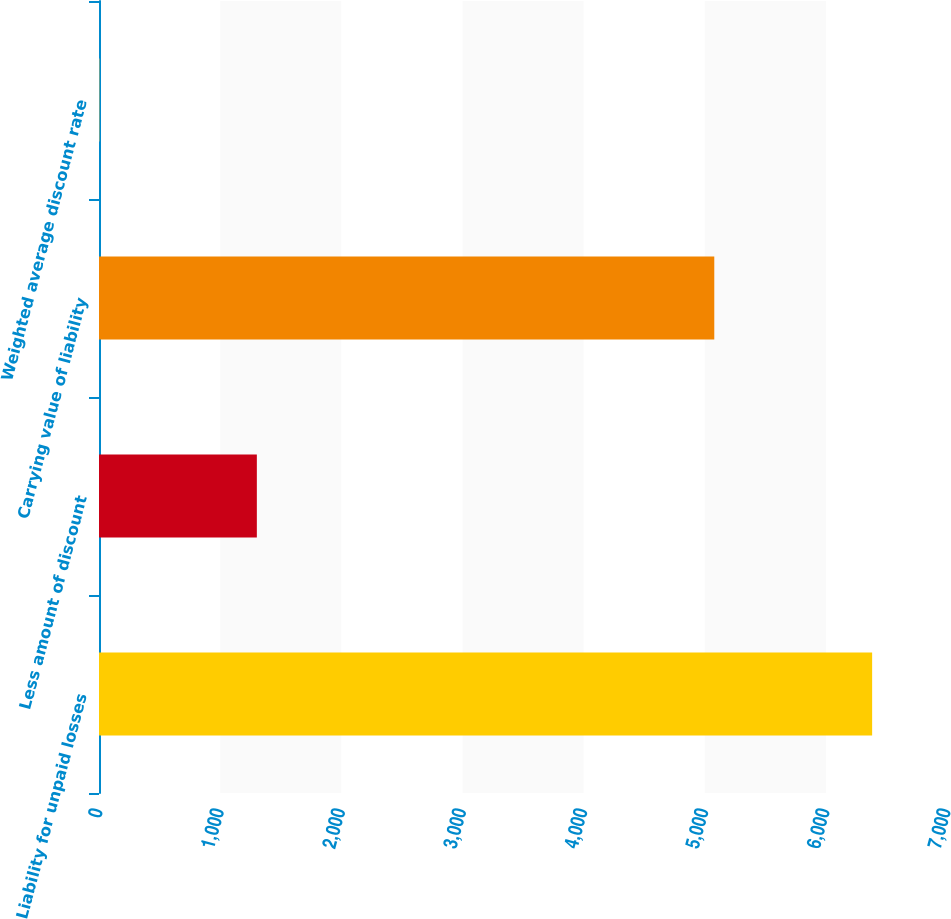Convert chart. <chart><loc_0><loc_0><loc_500><loc_500><bar_chart><fcel>Liability for unpaid losses<fcel>Less amount of discount<fcel>Carrying value of liability<fcel>Weighted average discount rate<nl><fcel>6382<fcel>1303<fcel>5079<fcel>4.3<nl></chart> 